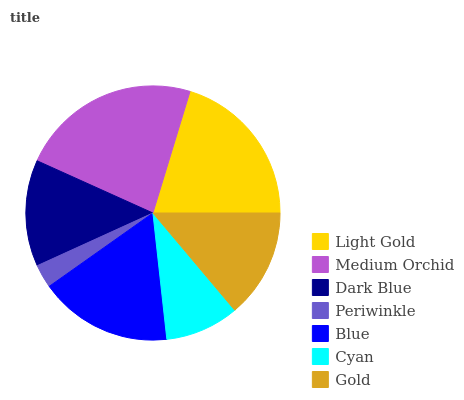Is Periwinkle the minimum?
Answer yes or no. Yes. Is Medium Orchid the maximum?
Answer yes or no. Yes. Is Dark Blue the minimum?
Answer yes or no. No. Is Dark Blue the maximum?
Answer yes or no. No. Is Medium Orchid greater than Dark Blue?
Answer yes or no. Yes. Is Dark Blue less than Medium Orchid?
Answer yes or no. Yes. Is Dark Blue greater than Medium Orchid?
Answer yes or no. No. Is Medium Orchid less than Dark Blue?
Answer yes or no. No. Is Gold the high median?
Answer yes or no. Yes. Is Gold the low median?
Answer yes or no. Yes. Is Dark Blue the high median?
Answer yes or no. No. Is Dark Blue the low median?
Answer yes or no. No. 